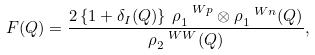Convert formula to latex. <formula><loc_0><loc_0><loc_500><loc_500>F ( Q ) = \frac { 2 \left \{ 1 + \delta _ { I } ( Q ) \right \} \, \rho _ { 1 } ^ { \ W p } \otimes \rho _ { 1 } ^ { \ W n } ( Q ) } { \rho _ { 2 } ^ { \ W W } ( Q ) } ,</formula> 